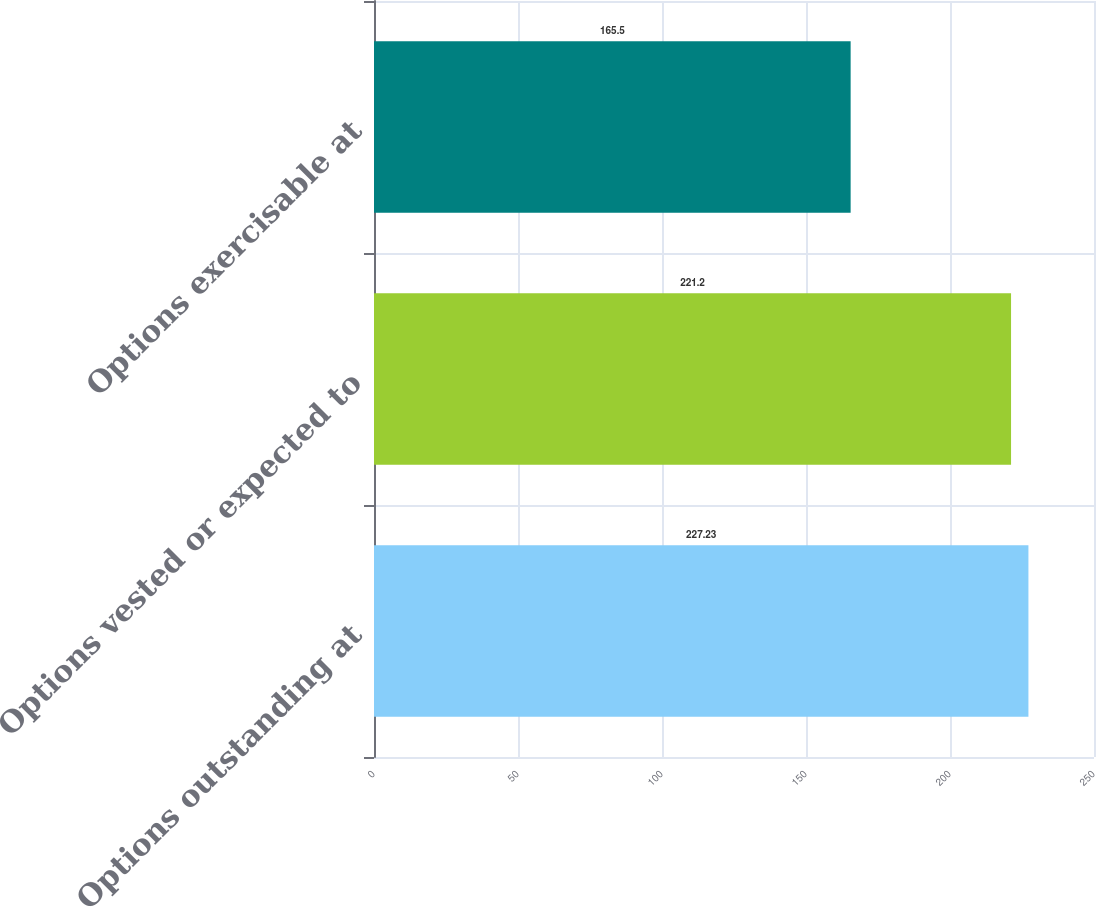Convert chart to OTSL. <chart><loc_0><loc_0><loc_500><loc_500><bar_chart><fcel>Options outstanding at<fcel>Options vested or expected to<fcel>Options exercisable at<nl><fcel>227.23<fcel>221.2<fcel>165.5<nl></chart> 